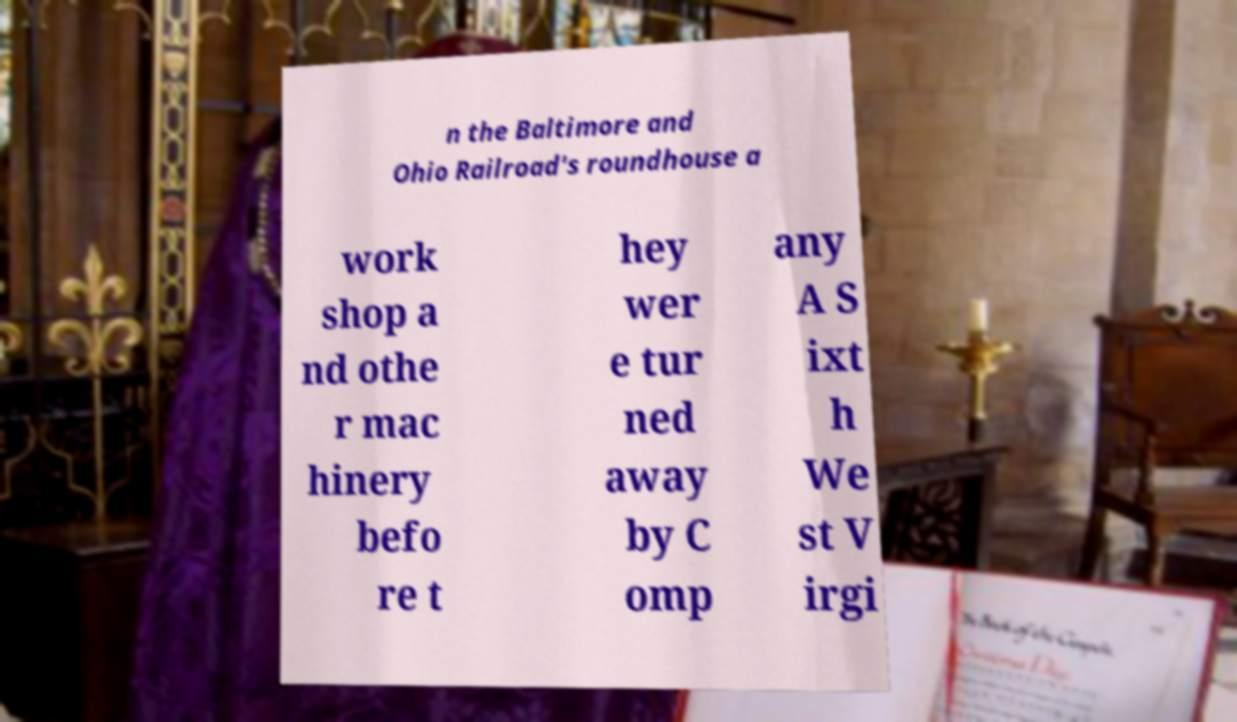Please read and relay the text visible in this image. What does it say? n the Baltimore and Ohio Railroad's roundhouse a work shop a nd othe r mac hinery befo re t hey wer e tur ned away by C omp any A S ixt h We st V irgi 